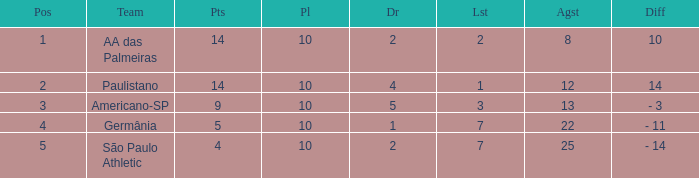What is the Against when the drawn is 5? 13.0. 